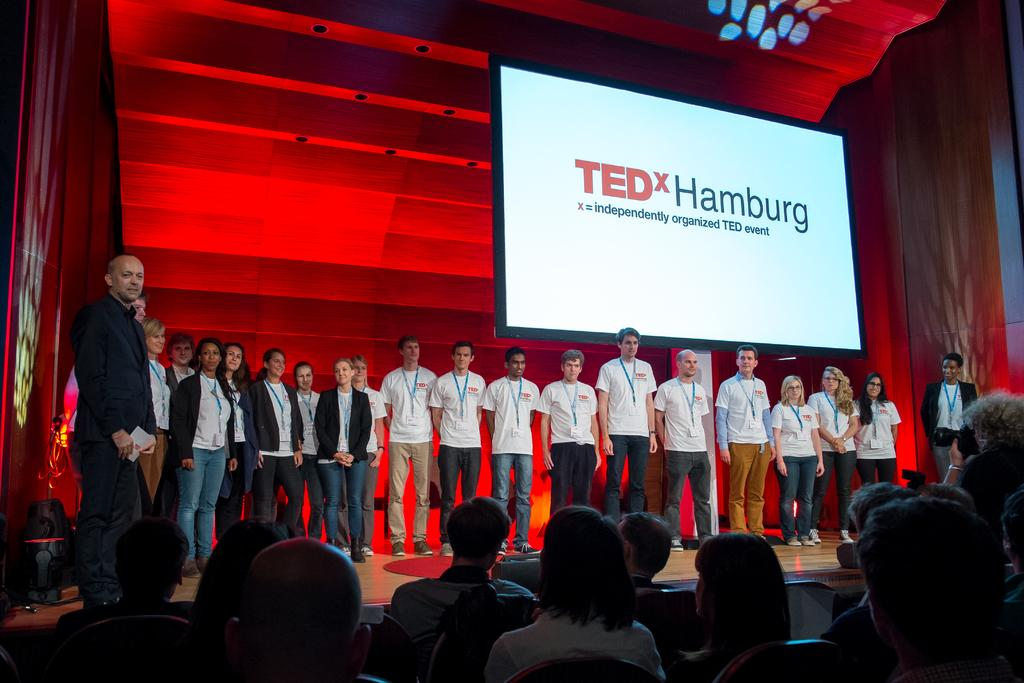How many people are in the image? There is a group of people in the image. What are the people doing in the image? Some people are standing on the floor, and some people are sitting on chairs. What can be seen on the screen in the image? The facts do not specify what is on the screen, so we cannot answer that question definitively. What objects are present in the image? There are objects present in the image, but the facts do not specify what they are. How many squirrels are climbing on the thread in the image? There are no squirrels or threads present in the image. What territory is being claimed by the people in the image? The facts do not mention any territorial claims or disputes in the image. 